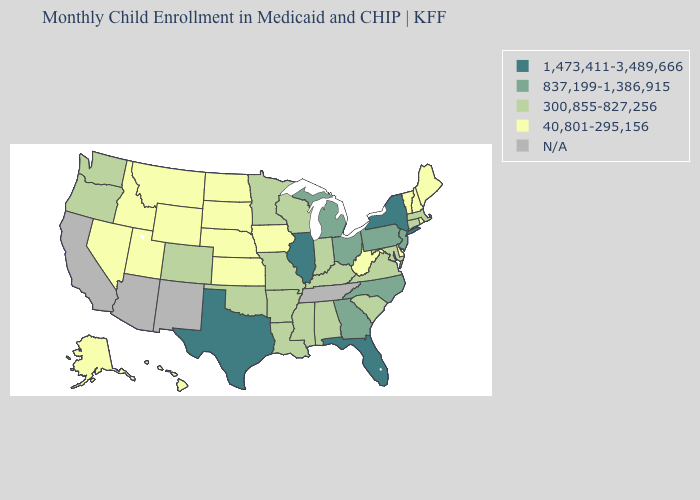What is the value of Iowa?
Keep it brief. 40,801-295,156. What is the highest value in the USA?
Short answer required. 1,473,411-3,489,666. Name the states that have a value in the range 40,801-295,156?
Quick response, please. Alaska, Delaware, Hawaii, Idaho, Iowa, Kansas, Maine, Montana, Nebraska, Nevada, New Hampshire, North Dakota, Rhode Island, South Dakota, Utah, Vermont, West Virginia, Wyoming. Among the states that border Ohio , which have the highest value?
Keep it brief. Michigan, Pennsylvania. Does Florida have the highest value in the South?
Concise answer only. Yes. Name the states that have a value in the range N/A?
Be succinct. Arizona, California, New Mexico, Tennessee. Does Nevada have the lowest value in the West?
Be succinct. Yes. What is the value of Rhode Island?
Answer briefly. 40,801-295,156. Does New York have the highest value in the USA?
Quick response, please. Yes. Does Montana have the highest value in the USA?
Give a very brief answer. No. What is the value of Colorado?
Be succinct. 300,855-827,256. Does Idaho have the highest value in the West?
Concise answer only. No. 